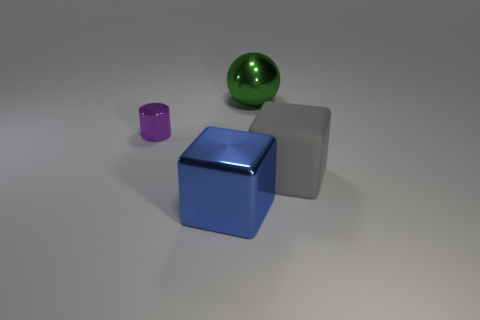Add 2 large red rubber blocks. How many objects exist? 6 Subtract all spheres. How many objects are left? 3 Add 3 big shiny things. How many big shiny things are left? 5 Add 2 gray metal blocks. How many gray metal blocks exist? 2 Subtract 0 yellow blocks. How many objects are left? 4 Subtract all purple things. Subtract all green things. How many objects are left? 2 